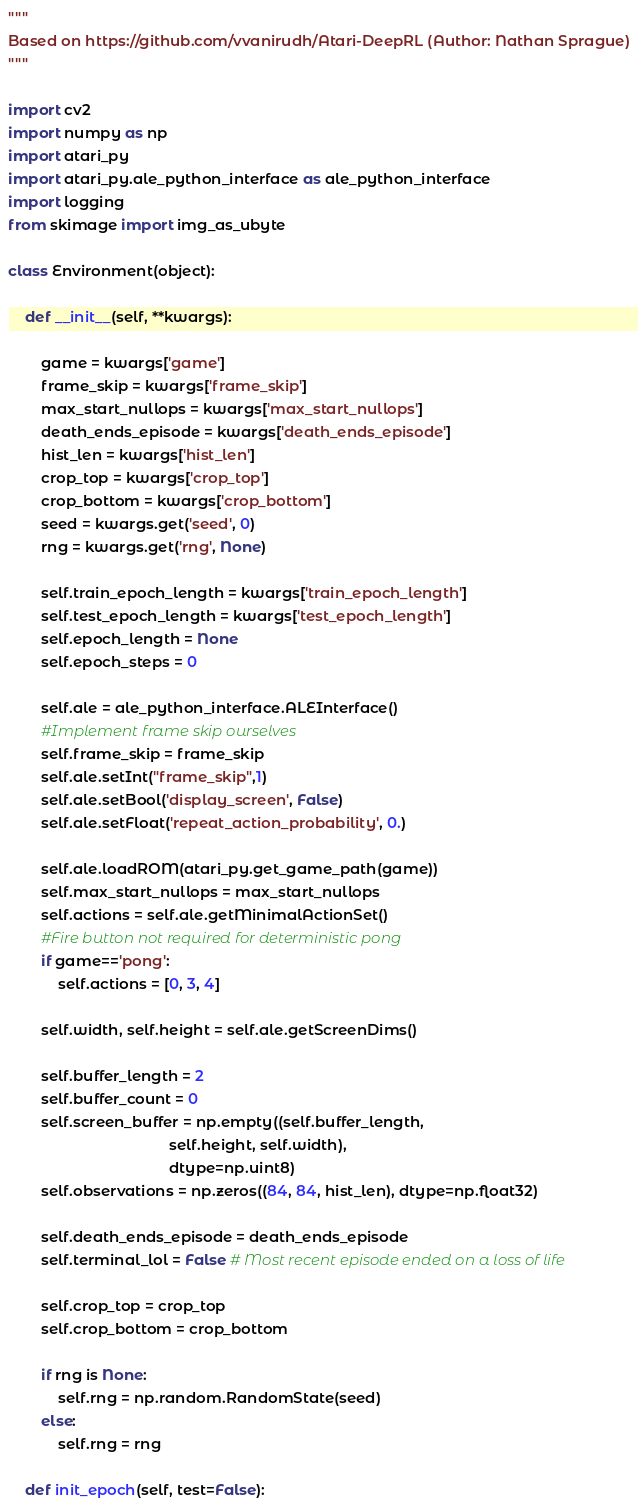<code> <loc_0><loc_0><loc_500><loc_500><_Python_>"""
Based on https://github.com/vvanirudh/Atari-DeepRL (Author: Nathan Sprague)
"""

import cv2
import numpy as np
import atari_py
import atari_py.ale_python_interface as ale_python_interface
import logging
from skimage import img_as_ubyte

class Environment(object):

	def __init__(self, **kwargs):

		game = kwargs['game']
		frame_skip = kwargs['frame_skip']
		max_start_nullops = kwargs['max_start_nullops']
		death_ends_episode = kwargs['death_ends_episode']
		hist_len = kwargs['hist_len']
		crop_top = kwargs['crop_top']
		crop_bottom = kwargs['crop_bottom']
		seed = kwargs.get('seed', 0)
		rng = kwargs.get('rng', None)

		self.train_epoch_length = kwargs['train_epoch_length']
		self.test_epoch_length = kwargs['test_epoch_length']
		self.epoch_length = None
		self.epoch_steps = 0

		self.ale = ale_python_interface.ALEInterface()
		#Implement frame skip ourselves
		self.frame_skip = frame_skip
		self.ale.setInt("frame_skip",1)
		self.ale.setBool('display_screen', False)
		self.ale.setFloat('repeat_action_probability', 0.)

		self.ale.loadROM(atari_py.get_game_path(game))
		self.max_start_nullops = max_start_nullops
		self.actions = self.ale.getMinimalActionSet()
		#Fire button not required for deterministic pong
		if game=='pong':
			self.actions = [0, 3, 4]

		self.width, self.height = self.ale.getScreenDims()

		self.buffer_length = 2
		self.buffer_count = 0
		self.screen_buffer = np.empty((self.buffer_length,
									   self.height, self.width),
									   dtype=np.uint8)
		self.observations = np.zeros((84, 84, hist_len), dtype=np.float32)

		self.death_ends_episode = death_ends_episode
		self.terminal_lol = False # Most recent episode ended on a loss of life

		self.crop_top = crop_top
		self.crop_bottom = crop_bottom

		if rng is None:
			self.rng = np.random.RandomState(seed)
		else:
			self.rng = rng

	def init_epoch(self, test=False):</code> 